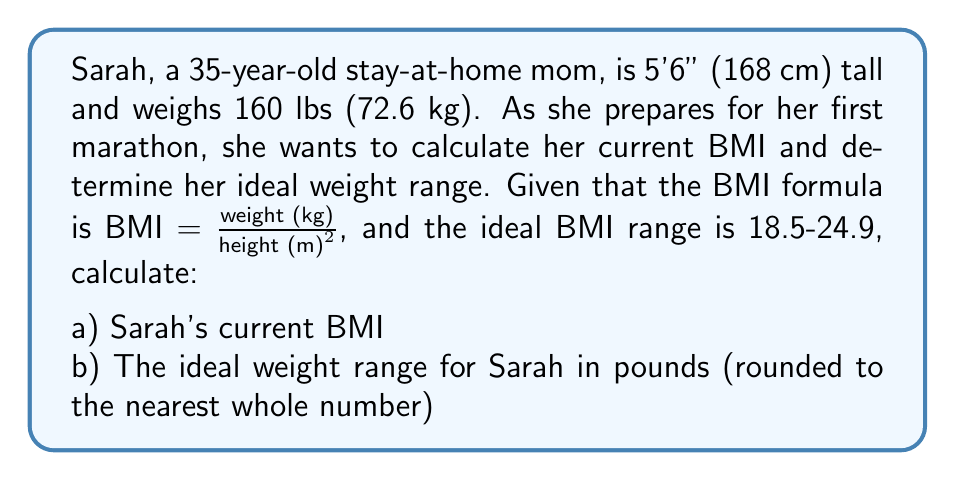Could you help me with this problem? Let's approach this step-by-step:

a) Calculating Sarah's current BMI:

1. Convert height to meters: 168 cm = 1.68 m
2. Use the BMI formula:

   $$BMI = \frac{weight (kg)}{height (m)^2} = \frac{72.6}{1.68^2} = \frac{72.6}{2.8224} \approx 25.72$$

b) Determining Sarah's ideal weight range:

1. Use the BMI formula and solve for weight:

   $$weight (kg) = BMI \times height (m)^2$$

2. Calculate the weight for the lower BMI limit (18.5):

   $$weight_{min} = 18.5 \times 1.68^2 = 18.5 \times 2.8224 = 52.21 kg$$

3. Calculate the weight for the upper BMI limit (24.9):

   $$weight_{max} = 24.9 \times 1.68^2 = 24.9 \times 2.8224 = 70.28 kg$$

4. Convert the weight range from kg to lbs (1 kg ≈ 2.20462 lbs):

   $$weight_{min} (lbs) = 52.21 \times 2.20462 \approx 115.13 lbs$$
   $$weight_{max} (lbs) = 70.28 \times 2.20462 \approx 154.94 lbs$$

5. Round to the nearest whole number:
   115 lbs to 155 lbs
Answer: a) Sarah's current BMI is approximately 25.72.
b) Sarah's ideal weight range is 115 lbs to 155 lbs. 